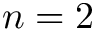<formula> <loc_0><loc_0><loc_500><loc_500>n = 2</formula> 